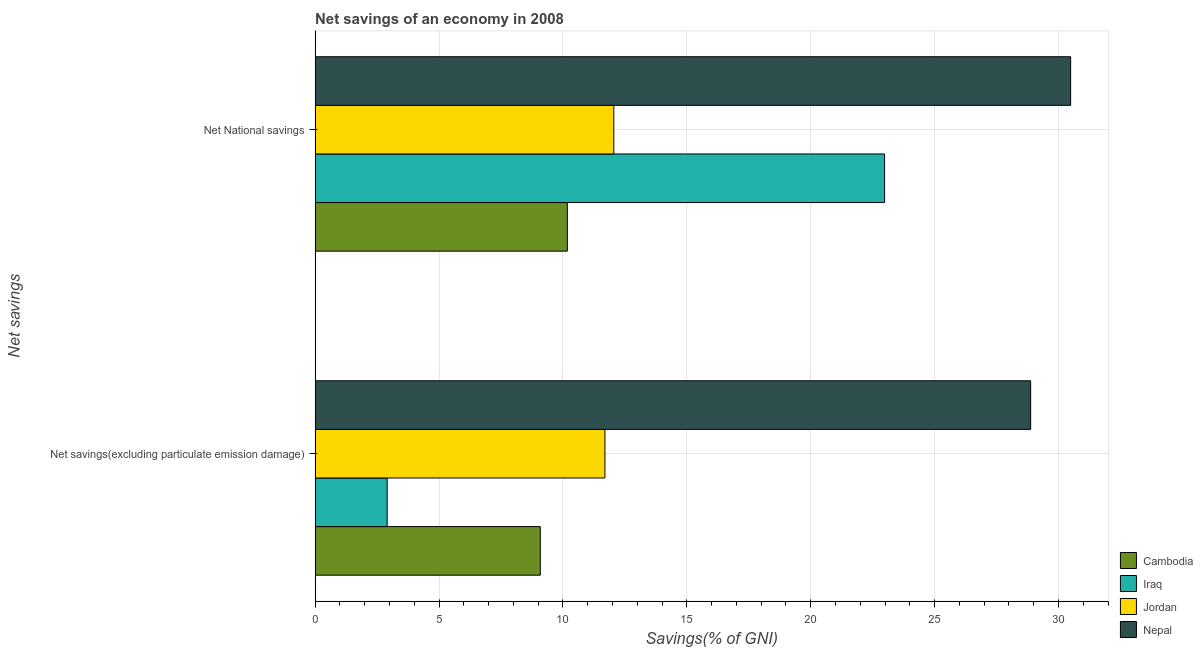How many different coloured bars are there?
Make the answer very short. 4. Are the number of bars per tick equal to the number of legend labels?
Your answer should be very brief. Yes. Are the number of bars on each tick of the Y-axis equal?
Your answer should be very brief. Yes. How many bars are there on the 1st tick from the bottom?
Keep it short and to the point. 4. What is the label of the 1st group of bars from the top?
Offer a very short reply. Net National savings. What is the net national savings in Cambodia?
Your response must be concise. 10.18. Across all countries, what is the maximum net savings(excluding particulate emission damage)?
Provide a succinct answer. 28.87. Across all countries, what is the minimum net national savings?
Your response must be concise. 10.18. In which country was the net national savings maximum?
Offer a very short reply. Nepal. In which country was the net savings(excluding particulate emission damage) minimum?
Your answer should be very brief. Iraq. What is the total net national savings in the graph?
Provide a succinct answer. 75.7. What is the difference between the net savings(excluding particulate emission damage) in Iraq and that in Nepal?
Offer a terse response. -25.97. What is the difference between the net national savings in Cambodia and the net savings(excluding particulate emission damage) in Jordan?
Your response must be concise. -1.52. What is the average net savings(excluding particulate emission damage) per country?
Your response must be concise. 13.14. What is the difference between the net savings(excluding particulate emission damage) and net national savings in Cambodia?
Keep it short and to the point. -1.09. In how many countries, is the net savings(excluding particulate emission damage) greater than 28 %?
Make the answer very short. 1. What is the ratio of the net savings(excluding particulate emission damage) in Cambodia to that in Jordan?
Give a very brief answer. 0.78. Is the net savings(excluding particulate emission damage) in Iraq less than that in Jordan?
Provide a succinct answer. Yes. In how many countries, is the net national savings greater than the average net national savings taken over all countries?
Your answer should be compact. 2. What does the 4th bar from the top in Net savings(excluding particulate emission damage) represents?
Provide a short and direct response. Cambodia. What does the 2nd bar from the bottom in Net savings(excluding particulate emission damage) represents?
Provide a succinct answer. Iraq. How many bars are there?
Ensure brevity in your answer.  8. Are all the bars in the graph horizontal?
Provide a short and direct response. Yes. How many countries are there in the graph?
Make the answer very short. 4. What is the title of the graph?
Ensure brevity in your answer.  Net savings of an economy in 2008. Does "West Bank and Gaza" appear as one of the legend labels in the graph?
Make the answer very short. No. What is the label or title of the X-axis?
Offer a terse response. Savings(% of GNI). What is the label or title of the Y-axis?
Provide a short and direct response. Net savings. What is the Savings(% of GNI) in Cambodia in Net savings(excluding particulate emission damage)?
Provide a succinct answer. 9.09. What is the Savings(% of GNI) in Iraq in Net savings(excluding particulate emission damage)?
Provide a succinct answer. 2.91. What is the Savings(% of GNI) of Jordan in Net savings(excluding particulate emission damage)?
Make the answer very short. 11.7. What is the Savings(% of GNI) of Nepal in Net savings(excluding particulate emission damage)?
Keep it short and to the point. 28.87. What is the Savings(% of GNI) of Cambodia in Net National savings?
Provide a succinct answer. 10.18. What is the Savings(% of GNI) of Iraq in Net National savings?
Offer a very short reply. 22.98. What is the Savings(% of GNI) of Jordan in Net National savings?
Provide a succinct answer. 12.05. What is the Savings(% of GNI) in Nepal in Net National savings?
Keep it short and to the point. 30.49. Across all Net savings, what is the maximum Savings(% of GNI) of Cambodia?
Keep it short and to the point. 10.18. Across all Net savings, what is the maximum Savings(% of GNI) in Iraq?
Keep it short and to the point. 22.98. Across all Net savings, what is the maximum Savings(% of GNI) in Jordan?
Give a very brief answer. 12.05. Across all Net savings, what is the maximum Savings(% of GNI) in Nepal?
Offer a terse response. 30.49. Across all Net savings, what is the minimum Savings(% of GNI) of Cambodia?
Your response must be concise. 9.09. Across all Net savings, what is the minimum Savings(% of GNI) of Iraq?
Make the answer very short. 2.91. Across all Net savings, what is the minimum Savings(% of GNI) of Jordan?
Provide a short and direct response. 11.7. Across all Net savings, what is the minimum Savings(% of GNI) of Nepal?
Your response must be concise. 28.87. What is the total Savings(% of GNI) of Cambodia in the graph?
Give a very brief answer. 19.27. What is the total Savings(% of GNI) of Iraq in the graph?
Provide a short and direct response. 25.89. What is the total Savings(% of GNI) of Jordan in the graph?
Give a very brief answer. 23.75. What is the total Savings(% of GNI) of Nepal in the graph?
Your answer should be compact. 59.36. What is the difference between the Savings(% of GNI) of Cambodia in Net savings(excluding particulate emission damage) and that in Net National savings?
Your answer should be very brief. -1.09. What is the difference between the Savings(% of GNI) of Iraq in Net savings(excluding particulate emission damage) and that in Net National savings?
Your answer should be very brief. -20.07. What is the difference between the Savings(% of GNI) of Jordan in Net savings(excluding particulate emission damage) and that in Net National savings?
Your response must be concise. -0.36. What is the difference between the Savings(% of GNI) in Nepal in Net savings(excluding particulate emission damage) and that in Net National savings?
Offer a terse response. -1.61. What is the difference between the Savings(% of GNI) in Cambodia in Net savings(excluding particulate emission damage) and the Savings(% of GNI) in Iraq in Net National savings?
Your answer should be very brief. -13.89. What is the difference between the Savings(% of GNI) in Cambodia in Net savings(excluding particulate emission damage) and the Savings(% of GNI) in Jordan in Net National savings?
Give a very brief answer. -2.97. What is the difference between the Savings(% of GNI) in Cambodia in Net savings(excluding particulate emission damage) and the Savings(% of GNI) in Nepal in Net National savings?
Your answer should be compact. -21.4. What is the difference between the Savings(% of GNI) in Iraq in Net savings(excluding particulate emission damage) and the Savings(% of GNI) in Jordan in Net National savings?
Offer a very short reply. -9.15. What is the difference between the Savings(% of GNI) in Iraq in Net savings(excluding particulate emission damage) and the Savings(% of GNI) in Nepal in Net National savings?
Ensure brevity in your answer.  -27.58. What is the difference between the Savings(% of GNI) in Jordan in Net savings(excluding particulate emission damage) and the Savings(% of GNI) in Nepal in Net National savings?
Provide a succinct answer. -18.79. What is the average Savings(% of GNI) of Cambodia per Net savings?
Provide a short and direct response. 9.63. What is the average Savings(% of GNI) of Iraq per Net savings?
Provide a succinct answer. 12.94. What is the average Savings(% of GNI) of Jordan per Net savings?
Ensure brevity in your answer.  11.87. What is the average Savings(% of GNI) of Nepal per Net savings?
Offer a very short reply. 29.68. What is the difference between the Savings(% of GNI) in Cambodia and Savings(% of GNI) in Iraq in Net savings(excluding particulate emission damage)?
Offer a very short reply. 6.18. What is the difference between the Savings(% of GNI) of Cambodia and Savings(% of GNI) of Jordan in Net savings(excluding particulate emission damage)?
Your answer should be very brief. -2.61. What is the difference between the Savings(% of GNI) in Cambodia and Savings(% of GNI) in Nepal in Net savings(excluding particulate emission damage)?
Your answer should be very brief. -19.79. What is the difference between the Savings(% of GNI) in Iraq and Savings(% of GNI) in Jordan in Net savings(excluding particulate emission damage)?
Your answer should be very brief. -8.79. What is the difference between the Savings(% of GNI) of Iraq and Savings(% of GNI) of Nepal in Net savings(excluding particulate emission damage)?
Your response must be concise. -25.97. What is the difference between the Savings(% of GNI) in Jordan and Savings(% of GNI) in Nepal in Net savings(excluding particulate emission damage)?
Offer a very short reply. -17.18. What is the difference between the Savings(% of GNI) of Cambodia and Savings(% of GNI) of Iraq in Net National savings?
Give a very brief answer. -12.8. What is the difference between the Savings(% of GNI) of Cambodia and Savings(% of GNI) of Jordan in Net National savings?
Your response must be concise. -1.88. What is the difference between the Savings(% of GNI) in Cambodia and Savings(% of GNI) in Nepal in Net National savings?
Give a very brief answer. -20.31. What is the difference between the Savings(% of GNI) in Iraq and Savings(% of GNI) in Jordan in Net National savings?
Your answer should be very brief. 10.93. What is the difference between the Savings(% of GNI) of Iraq and Savings(% of GNI) of Nepal in Net National savings?
Your answer should be compact. -7.51. What is the difference between the Savings(% of GNI) in Jordan and Savings(% of GNI) in Nepal in Net National savings?
Give a very brief answer. -18.43. What is the ratio of the Savings(% of GNI) of Cambodia in Net savings(excluding particulate emission damage) to that in Net National savings?
Offer a terse response. 0.89. What is the ratio of the Savings(% of GNI) in Iraq in Net savings(excluding particulate emission damage) to that in Net National savings?
Your response must be concise. 0.13. What is the ratio of the Savings(% of GNI) of Jordan in Net savings(excluding particulate emission damage) to that in Net National savings?
Offer a terse response. 0.97. What is the ratio of the Savings(% of GNI) in Nepal in Net savings(excluding particulate emission damage) to that in Net National savings?
Your answer should be compact. 0.95. What is the difference between the highest and the second highest Savings(% of GNI) of Cambodia?
Your answer should be very brief. 1.09. What is the difference between the highest and the second highest Savings(% of GNI) in Iraq?
Make the answer very short. 20.07. What is the difference between the highest and the second highest Savings(% of GNI) in Jordan?
Offer a very short reply. 0.36. What is the difference between the highest and the second highest Savings(% of GNI) of Nepal?
Keep it short and to the point. 1.61. What is the difference between the highest and the lowest Savings(% of GNI) in Cambodia?
Offer a very short reply. 1.09. What is the difference between the highest and the lowest Savings(% of GNI) in Iraq?
Provide a short and direct response. 20.07. What is the difference between the highest and the lowest Savings(% of GNI) of Jordan?
Offer a terse response. 0.36. What is the difference between the highest and the lowest Savings(% of GNI) in Nepal?
Provide a short and direct response. 1.61. 